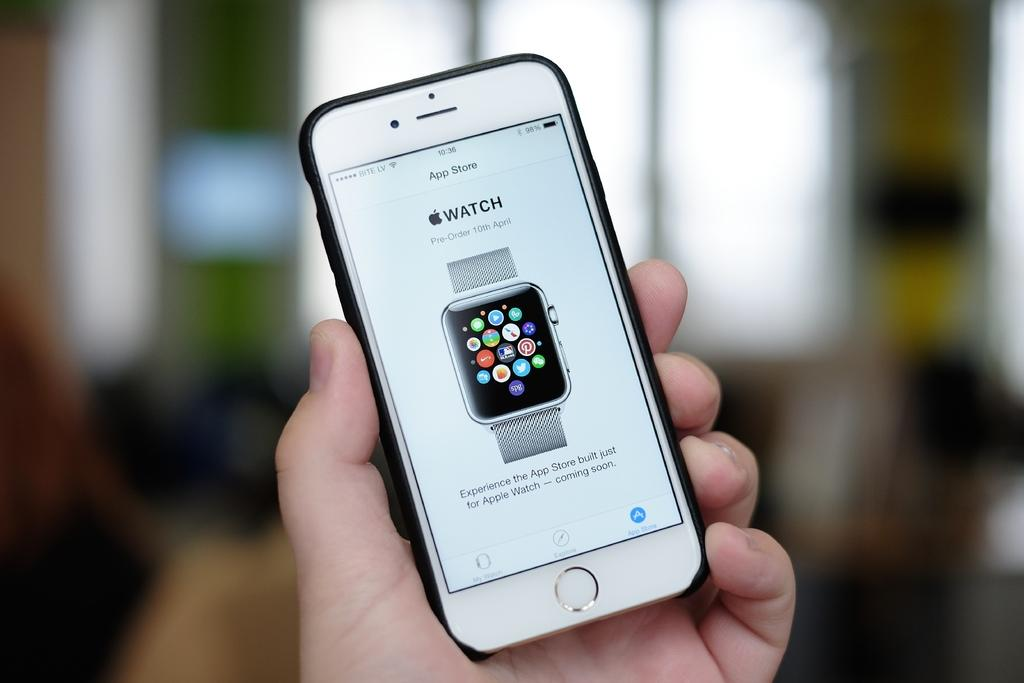<image>
Create a compact narrative representing the image presented. A person is holding an Apple iPhone that is displaying an Apple Watch Advertisement. 